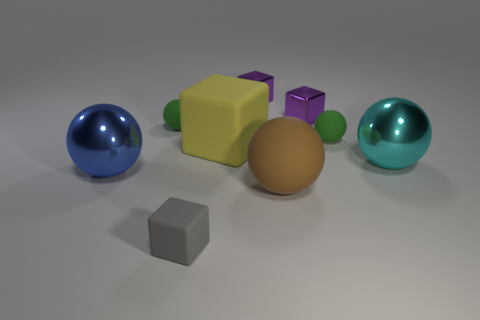Subtract all blue balls. How many balls are left? 4 Subtract all blue balls. How many balls are left? 4 Subtract 1 blocks. How many blocks are left? 3 Subtract all yellow spheres. Subtract all cyan cylinders. How many spheres are left? 5 Subtract all blocks. How many objects are left? 5 Add 1 cyan objects. How many cyan objects are left? 2 Add 6 small gray rubber cubes. How many small gray rubber cubes exist? 7 Subtract 0 blue blocks. How many objects are left? 9 Subtract all big blue objects. Subtract all yellow cubes. How many objects are left? 7 